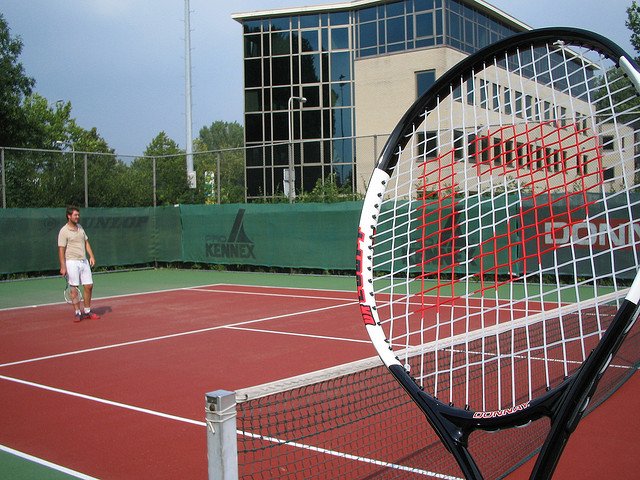What type of equipment is essential for the sport shown in the image? For the sport depicted, a tennis racket and tennis balls are essential equipment. Additionally, appropriate footwear for the court surface is important for players. 